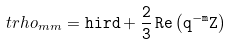Convert formula to latex. <formula><loc_0><loc_0><loc_500><loc_500>\ t r h o _ { m m } = \tt h i r d + \frac { 2 } { 3 } \, R e \left ( q ^ { - m } Z \right )</formula> 